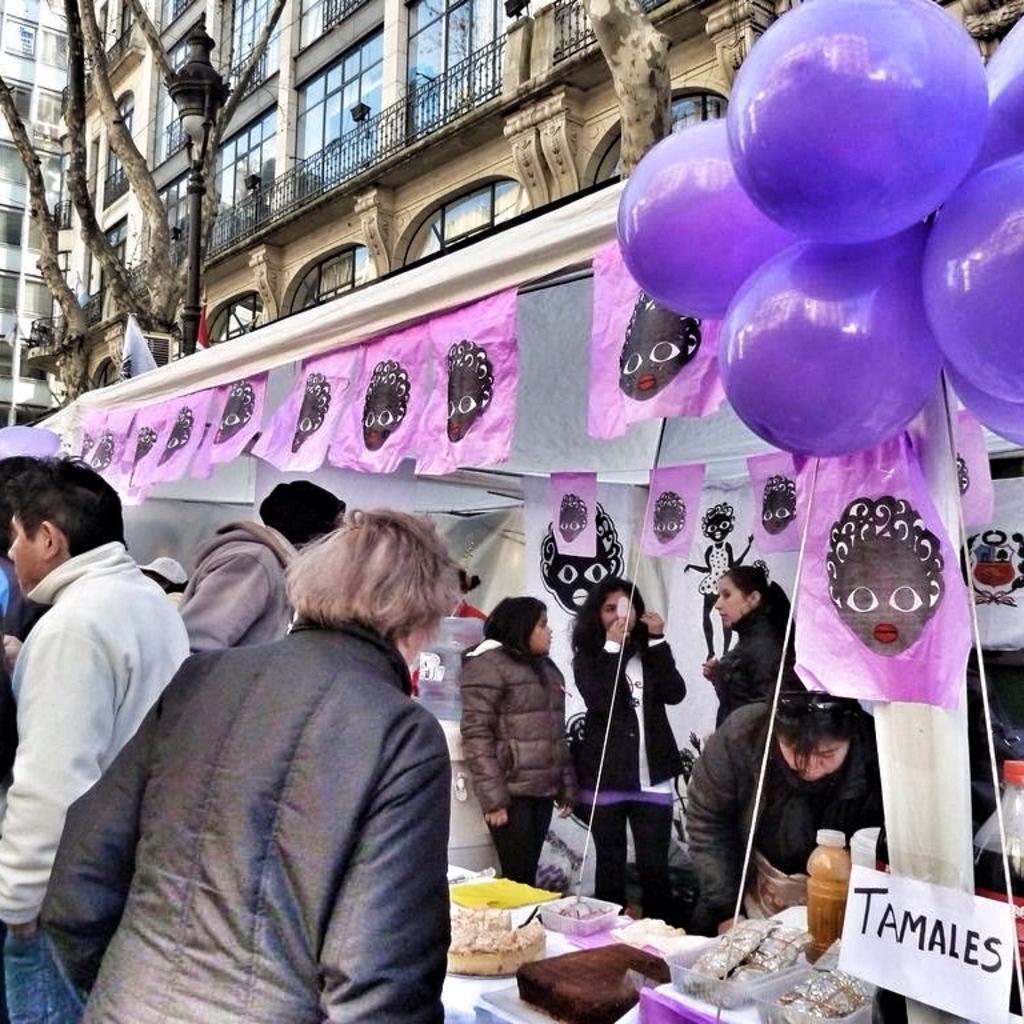In one or two sentences, can you explain what this image depicts? In this image I can see number of people wearing jackets and a stall of food. I can also see number of balloons, a building, a street light and a tree. 